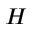<formula> <loc_0><loc_0><loc_500><loc_500>H</formula> 